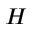<formula> <loc_0><loc_0><loc_500><loc_500>H</formula> 